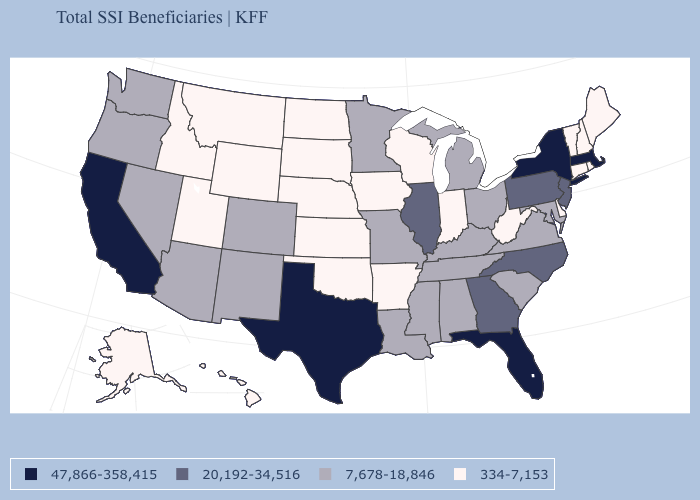Among the states that border New Jersey , which have the highest value?
Be succinct. New York. Among the states that border Washington , which have the highest value?
Write a very short answer. Oregon. Is the legend a continuous bar?
Give a very brief answer. No. What is the value of Alaska?
Keep it brief. 334-7,153. Name the states that have a value in the range 47,866-358,415?
Write a very short answer. California, Florida, Massachusetts, New York, Texas. Does Arkansas have the lowest value in the USA?
Short answer required. Yes. Name the states that have a value in the range 20,192-34,516?
Keep it brief. Georgia, Illinois, New Jersey, North Carolina, Pennsylvania. Name the states that have a value in the range 7,678-18,846?
Keep it brief. Alabama, Arizona, Colorado, Kentucky, Louisiana, Maryland, Michigan, Minnesota, Mississippi, Missouri, Nevada, New Mexico, Ohio, Oregon, South Carolina, Tennessee, Virginia, Washington. Does the first symbol in the legend represent the smallest category?
Short answer required. No. Which states have the lowest value in the USA?
Keep it brief. Alaska, Arkansas, Connecticut, Delaware, Hawaii, Idaho, Indiana, Iowa, Kansas, Maine, Montana, Nebraska, New Hampshire, North Dakota, Oklahoma, Rhode Island, South Dakota, Utah, Vermont, West Virginia, Wisconsin, Wyoming. Among the states that border Connecticut , which have the highest value?
Be succinct. Massachusetts, New York. Name the states that have a value in the range 20,192-34,516?
Write a very short answer. Georgia, Illinois, New Jersey, North Carolina, Pennsylvania. What is the value of Connecticut?
Be succinct. 334-7,153. Name the states that have a value in the range 47,866-358,415?
Quick response, please. California, Florida, Massachusetts, New York, Texas. What is the value of Oregon?
Write a very short answer. 7,678-18,846. 